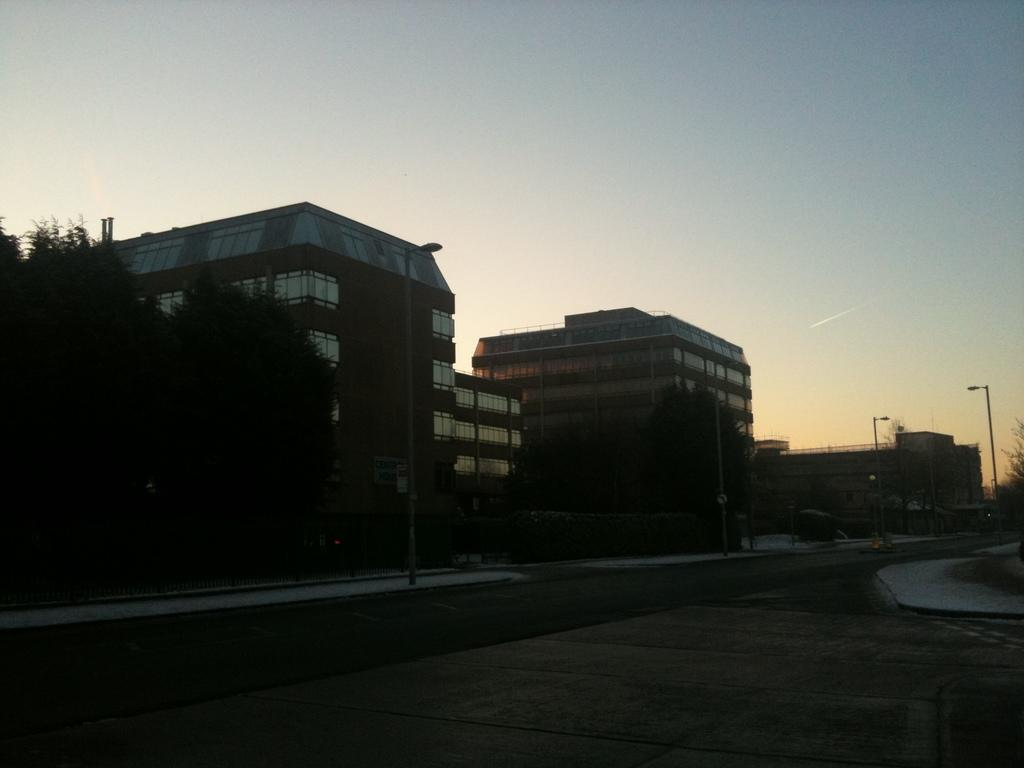What is the main feature of the image? There is an empty road in the image. What else can be seen along the road? Poles are visible in the image. What type of natural elements are present in the image? There are trees in the image. What type of man-made structures can be seen in the image? There are buildings in the image. Where is the hole in the image? There is no hole present in the image. How many steps are visible in the image? There are no steps visible in the image. 